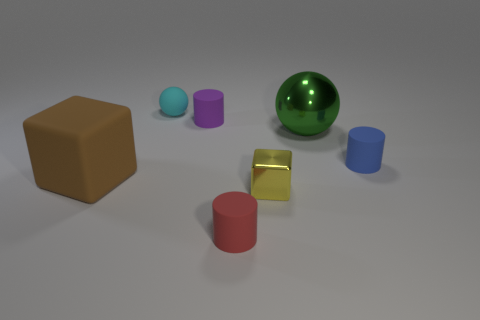Add 2 big cubes. How many objects exist? 9 Subtract all cubes. How many objects are left? 5 Add 7 blue cylinders. How many blue cylinders are left? 8 Add 7 tiny cyan shiny cubes. How many tiny cyan shiny cubes exist? 7 Subtract 1 brown blocks. How many objects are left? 6 Subtract all cylinders. Subtract all tiny yellow objects. How many objects are left? 3 